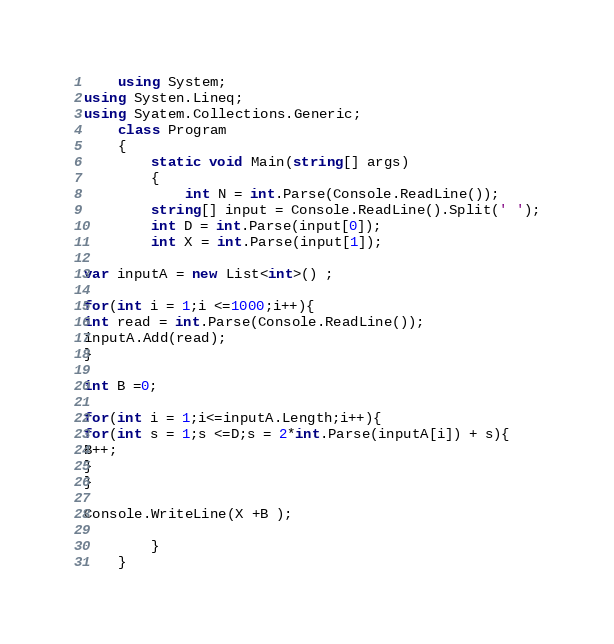Convert code to text. <code><loc_0><loc_0><loc_500><loc_500><_C#_>    using System;
using Systen.Lineq;
using Syatem.Collections.Generic;
    class Program
    {
    	static void Main(string[] args)
    	{
    		int N = int.Parse(Console.ReadLine());
		string[] input = Console.ReadLine().Split(' ');
		int D = int.Parse(input[0]);
		int X = int.Parse(input[1]);
                
var inputA = new List<int>() ;

for(int i = 1;i <=1000;i++){
int read = int.Parse(Console.ReadLine());
inputA.Add(read);
}

int B =0;

for(int i = 1;i<=inputA.Length;i++){
for(int s = 1;s <=D;s = 2*int.Parse(inputA[i]) + s){
B++;
}
}

Console.WriteLine(X +B );

    	}
    }</code> 